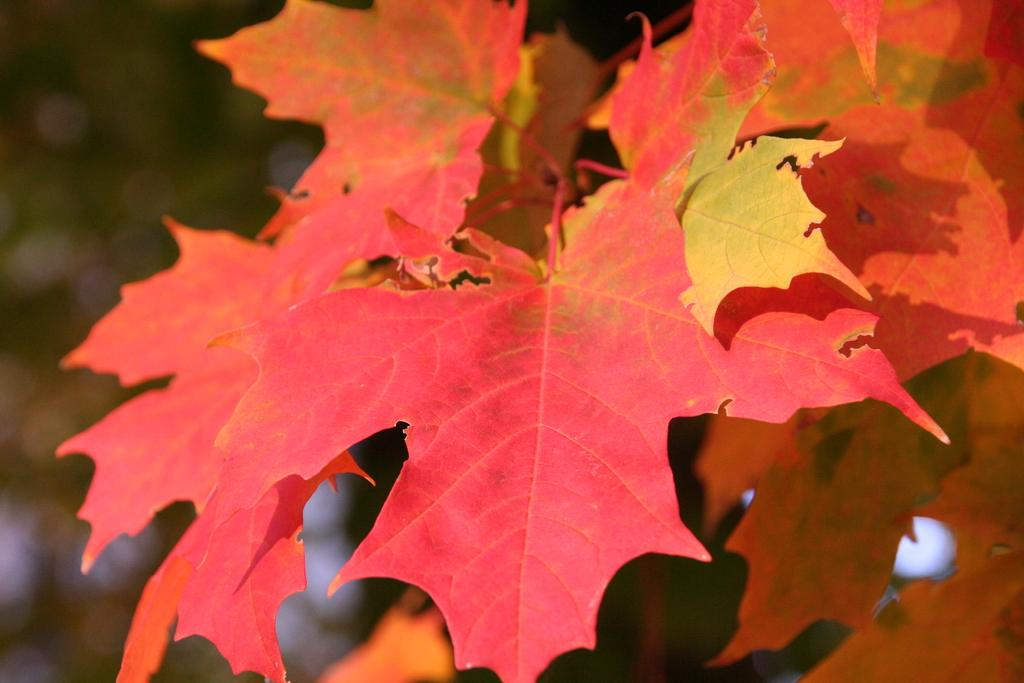What type of natural elements can be seen in the image? There are leaves in the image. What color are the leaves? The leaves are red in color. What type of veil can be seen covering the leaves in the image? There is no veil present in the image; the leaves are visible and not covered. 